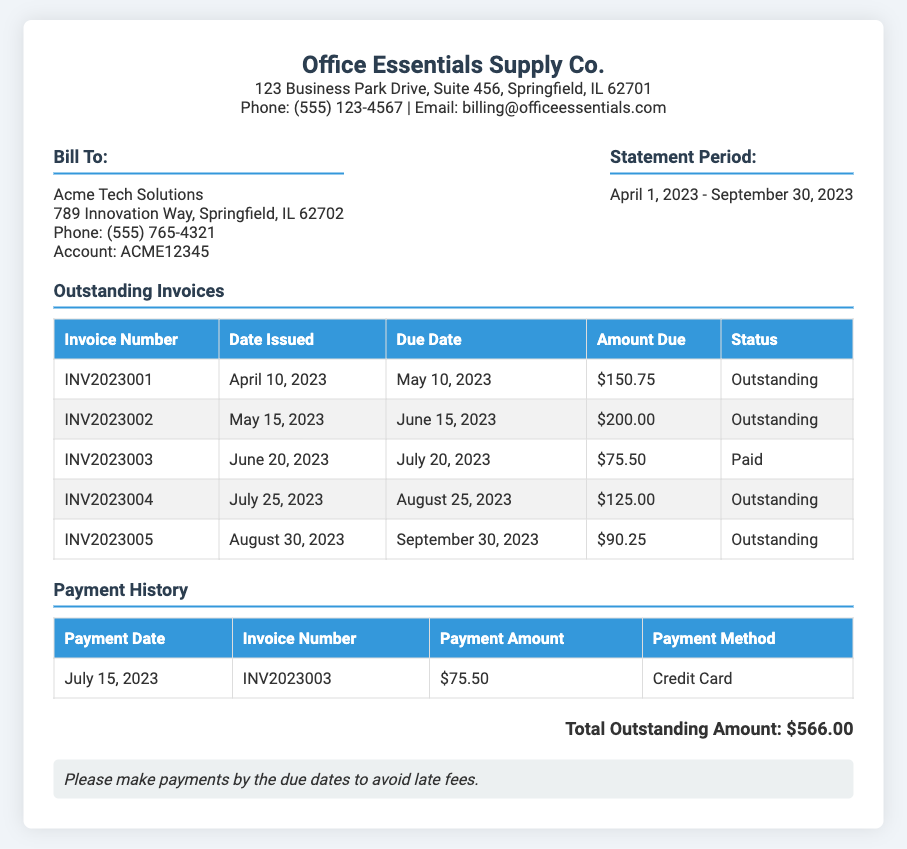What is the name of the company? The name of the company is prominently displayed at the top of the document.
Answer: Office Essentials Supply Co Who is the bill addressed to? The document provides the name of the customer to whom the bill is addressed.
Answer: Acme Tech Solutions What is the total outstanding amount? The total outstanding amount is calculated from the invoices that are still due.
Answer: $566.00 How many invoices are marked as outstanding? The document lists invoices with their respective statuses, from which the number of outstanding ones can be counted.
Answer: Four What is the due date for invoice INV2023002? The due date for each invoice is provided in the document next to the respective invoice number.
Answer: June 15, 2023 Which invoice was paid on July 15, 2023? The payment history section specifies which invoice was paid and on what date.
Answer: INV2023003 What payment method was used for the payment on July 15, 2023? The document includes the method of payment used for each payment in the payment history section.
Answer: Credit Card What is the statement period covered in this document? The statement period is explicitly mentioned under the customer information section of the document.
Answer: April 1, 2023 - September 30, 2023 What is the amount due for invoice INV2023005? Each outstanding invoice lists the amount due associated with it, which can be found in the table.
Answer: $90.25 